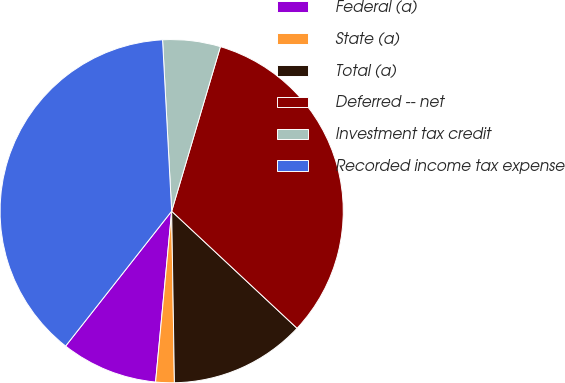Convert chart to OTSL. <chart><loc_0><loc_0><loc_500><loc_500><pie_chart><fcel>Federal (a)<fcel>State (a)<fcel>Total (a)<fcel>Deferred -- net<fcel>Investment tax credit<fcel>Recorded income tax expense<nl><fcel>9.11%<fcel>1.75%<fcel>12.79%<fcel>32.37%<fcel>5.43%<fcel>38.55%<nl></chart> 